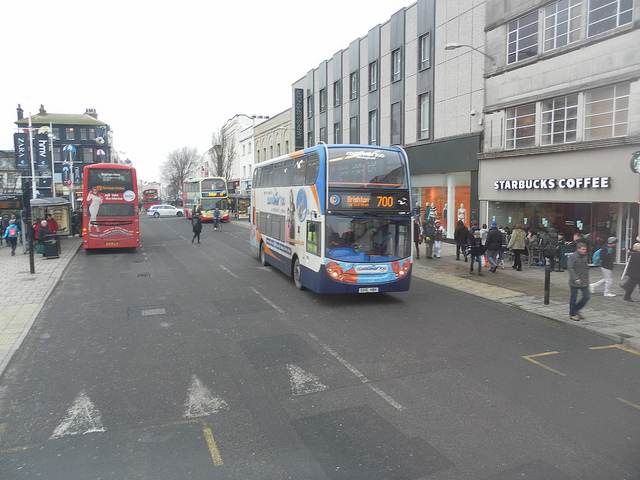What is this photo about? This photo captures a busy urban street scene. In the foreground, a prominent double-decker bus is on the move, with its headlights illuminating the way. The bus's license plate is clearly visible, adding a layer of detail to the image. Behind this main bus, several other buses are also visible, each with their headlights on, suggesting that it might be early morning or late evening. Streetlights line the street at regular intervals, contributing to the urban ambiance. The background features a bustling pedestrian sidewalk and various commercial outlets, including a noticeable Starbucks Coffee on the right, indicating a lively and active urban environment. 